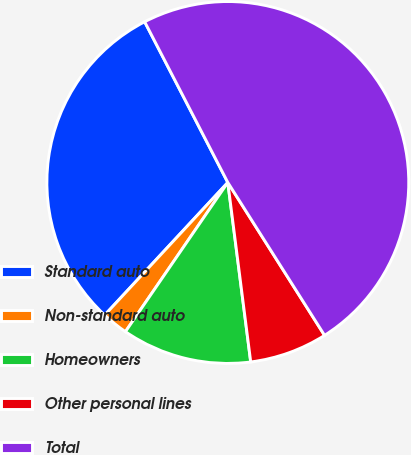<chart> <loc_0><loc_0><loc_500><loc_500><pie_chart><fcel>Standard auto<fcel>Non-standard auto<fcel>Homeowners<fcel>Other personal lines<fcel>Total<nl><fcel>30.49%<fcel>2.34%<fcel>11.59%<fcel>6.96%<fcel>48.62%<nl></chart> 